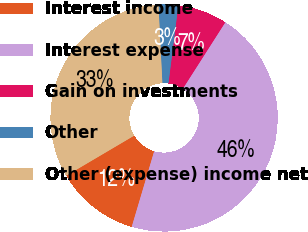Convert chart to OTSL. <chart><loc_0><loc_0><loc_500><loc_500><pie_chart><fcel>Interest income<fcel>Interest expense<fcel>Gain on investments<fcel>Other<fcel>Other (expense) income net<nl><fcel>11.92%<fcel>45.54%<fcel>7.06%<fcel>2.79%<fcel>32.69%<nl></chart> 